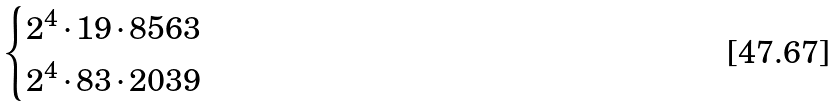Convert formula to latex. <formula><loc_0><loc_0><loc_500><loc_500>\begin{cases} 2 ^ { 4 } \cdot 1 9 \cdot 8 5 6 3 \\ 2 ^ { 4 } \cdot 8 3 \cdot 2 0 3 9 \end{cases}</formula> 